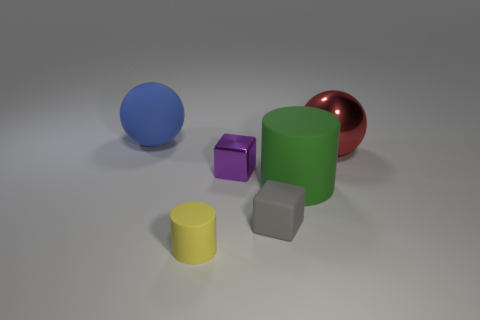Add 4 small cyan cubes. How many objects exist? 10 Subtract all balls. How many objects are left? 4 Add 1 purple blocks. How many purple blocks are left? 2 Add 3 matte cylinders. How many matte cylinders exist? 5 Subtract 0 brown cubes. How many objects are left? 6 Subtract all purple spheres. Subtract all cubes. How many objects are left? 4 